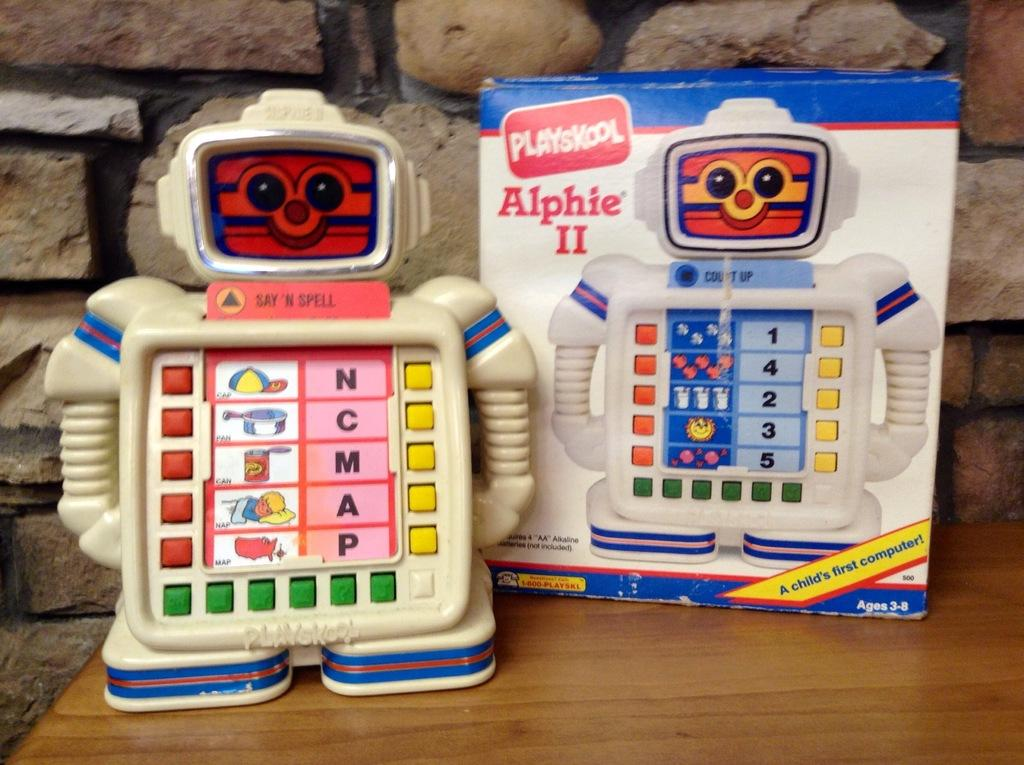What object is present in the image that is meant for play? There is a toy in the image. What is associated with the toy in the image? The toy's box is present in the image. Where are the toy and its box located in the image? Both the toy and its box are placed on a table. What can be seen in the background of the image? There is a wall in the background of the image. What type of creature can be seen interacting with the toy in the image? There is no creature present in the image; it only features a toy and its box. How does the toy connect to the dock in the image? There is no dock present in the image, and the toy is not connected to any dock. 